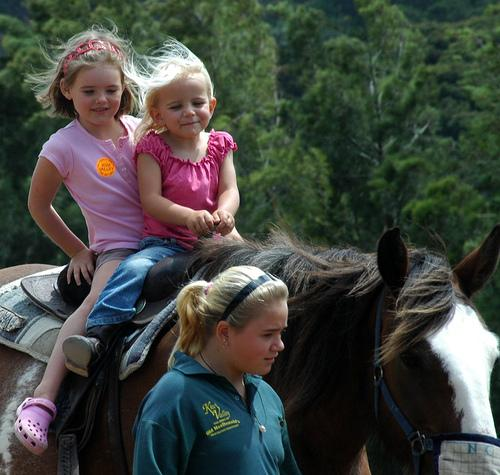What color is the person who is responsible for the safety of the two girls on horseback wearing? blue 